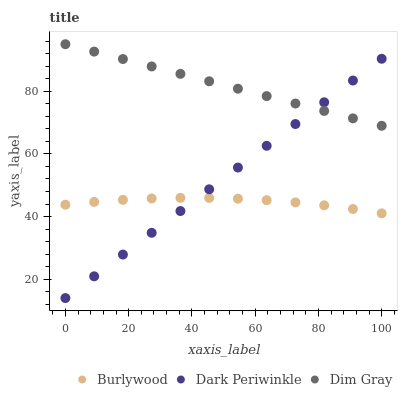Does Burlywood have the minimum area under the curve?
Answer yes or no. Yes. Does Dim Gray have the maximum area under the curve?
Answer yes or no. Yes. Does Dark Periwinkle have the minimum area under the curve?
Answer yes or no. No. Does Dark Periwinkle have the maximum area under the curve?
Answer yes or no. No. Is Dark Periwinkle the smoothest?
Answer yes or no. Yes. Is Burlywood the roughest?
Answer yes or no. Yes. Is Dim Gray the smoothest?
Answer yes or no. No. Is Dim Gray the roughest?
Answer yes or no. No. Does Dark Periwinkle have the lowest value?
Answer yes or no. Yes. Does Dim Gray have the lowest value?
Answer yes or no. No. Does Dim Gray have the highest value?
Answer yes or no. Yes. Does Dark Periwinkle have the highest value?
Answer yes or no. No. Is Burlywood less than Dim Gray?
Answer yes or no. Yes. Is Dim Gray greater than Burlywood?
Answer yes or no. Yes. Does Dark Periwinkle intersect Dim Gray?
Answer yes or no. Yes. Is Dark Periwinkle less than Dim Gray?
Answer yes or no. No. Is Dark Periwinkle greater than Dim Gray?
Answer yes or no. No. Does Burlywood intersect Dim Gray?
Answer yes or no. No. 